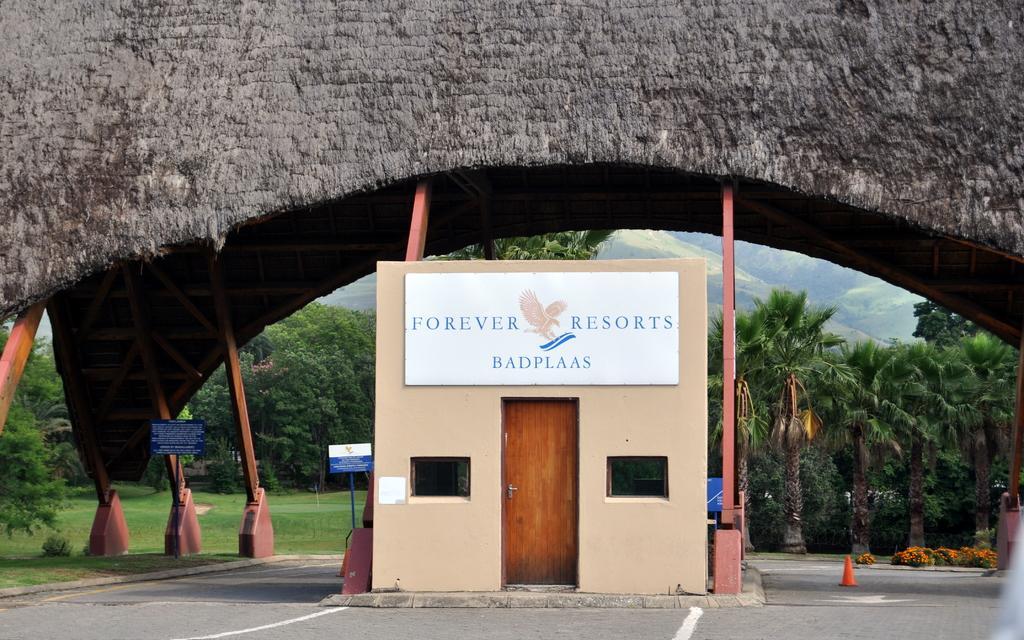Please provide a concise description of this image. In this image I can see a building,window and door. Back I can see bridge,trees and mountains. 